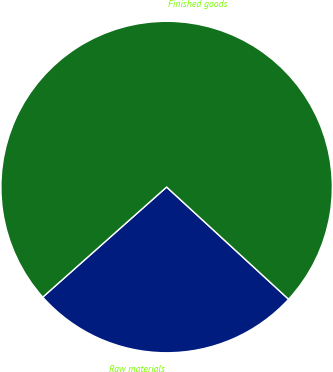Convert chart to OTSL. <chart><loc_0><loc_0><loc_500><loc_500><pie_chart><fcel>Raw materials<fcel>Finished goods<nl><fcel>26.6%<fcel>73.4%<nl></chart> 